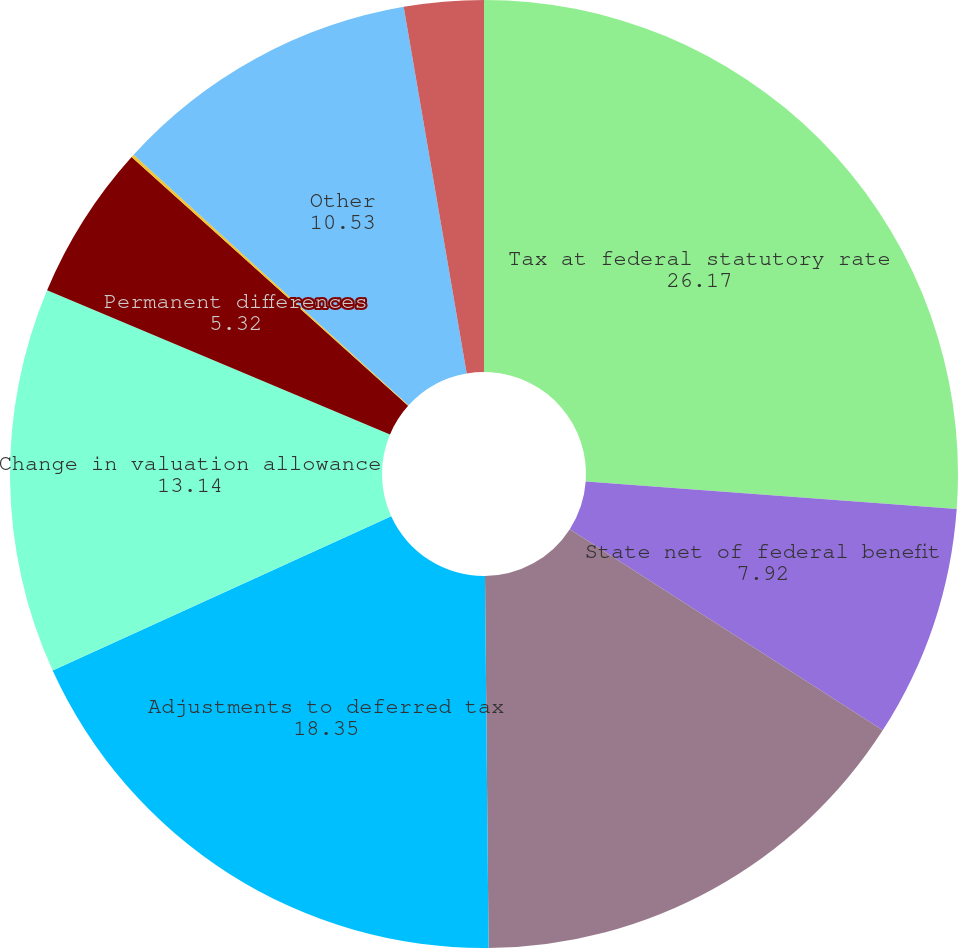Convert chart. <chart><loc_0><loc_0><loc_500><loc_500><pie_chart><fcel>Tax at federal statutory rate<fcel>State net of federal benefit<fcel>Research and other credits<fcel>Adjustments to deferred tax<fcel>Change in valuation allowance<fcel>Permanent differences<fcel>Foreign rate adjustments<fcel>Other<fcel>Total tax provision (benefit)<nl><fcel>26.17%<fcel>7.92%<fcel>15.75%<fcel>18.35%<fcel>13.14%<fcel>5.32%<fcel>0.1%<fcel>10.53%<fcel>2.71%<nl></chart> 